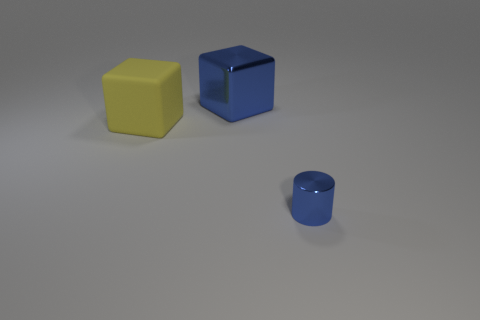Subtract 1 blocks. How many blocks are left? 1 Subtract all blocks. How many objects are left? 1 Add 2 gray cylinders. How many gray cylinders exist? 2 Add 2 tiny blue shiny objects. How many objects exist? 5 Subtract 0 brown cubes. How many objects are left? 3 Subtract all purple cubes. Subtract all cyan cylinders. How many cubes are left? 2 Subtract all yellow spheres. How many gray cylinders are left? 0 Subtract all small blue objects. Subtract all big yellow metal cylinders. How many objects are left? 2 Add 1 large yellow rubber objects. How many large yellow rubber objects are left? 2 